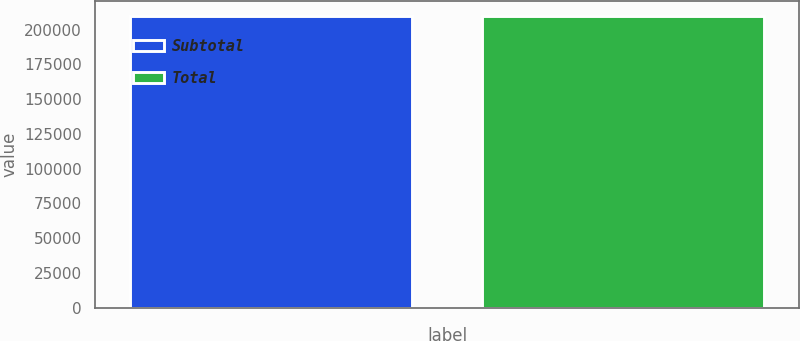Convert chart. <chart><loc_0><loc_0><loc_500><loc_500><bar_chart><fcel>Subtotal<fcel>Total<nl><fcel>210077<fcel>210077<nl></chart> 